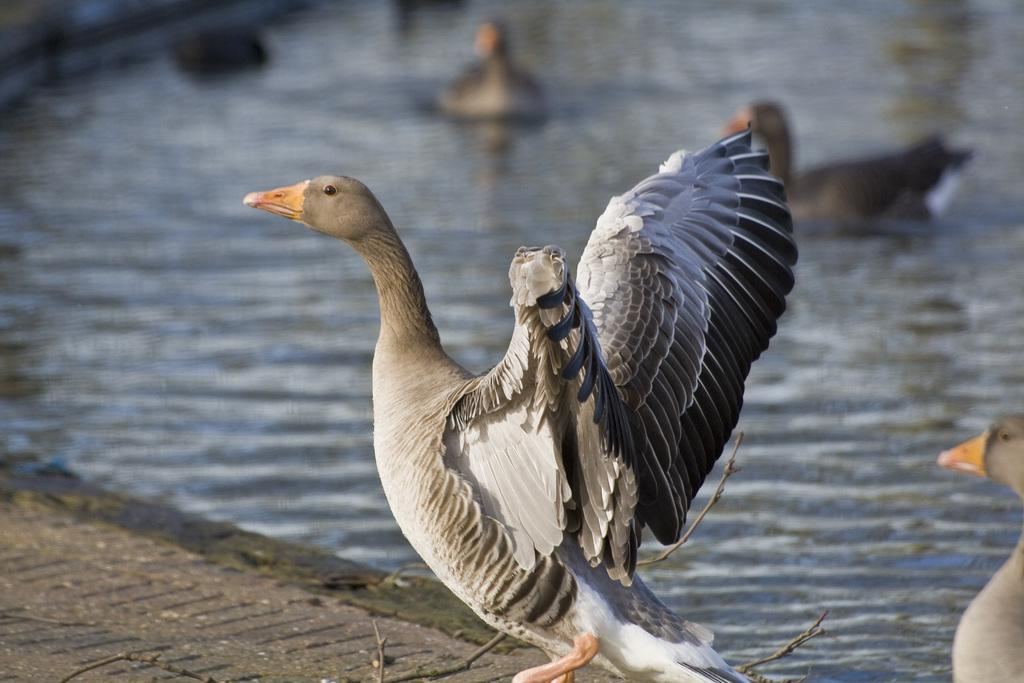What type of animals can be seen in the image? Birds can be seen in the image. What object is present in the image? There is a stick in the image. What natural element is visible in the image? Water is visible in the image. How would you describe the background of the image? The background of the image is blurred. Can you tell me how many maids are present in the image? There are no maids present in the image; it features birds, a stick, water, and a blurred background. What type of spark can be seen coming from the ground in the image? There is no spark or ground present in the image; it features birds, a stick, water, and a blurred background. 